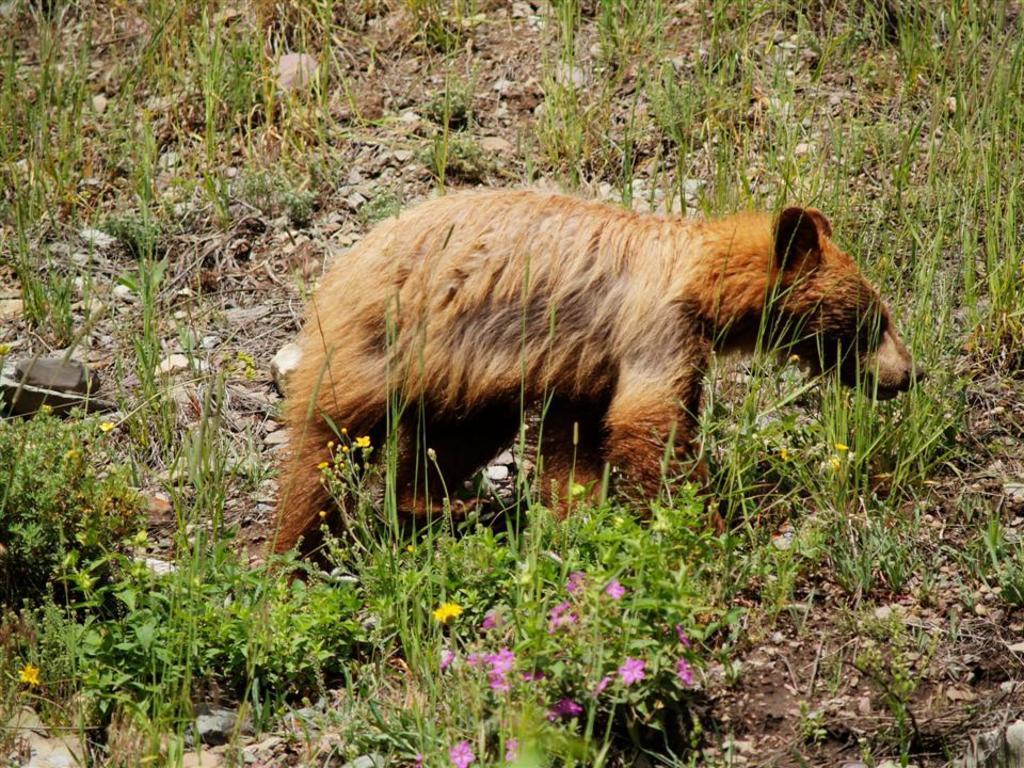Please provide a concise description of this image. In the center of the image there is a bear. In front of the image there are plants and flowers. At the bottom of the image there is grass on the surface. 